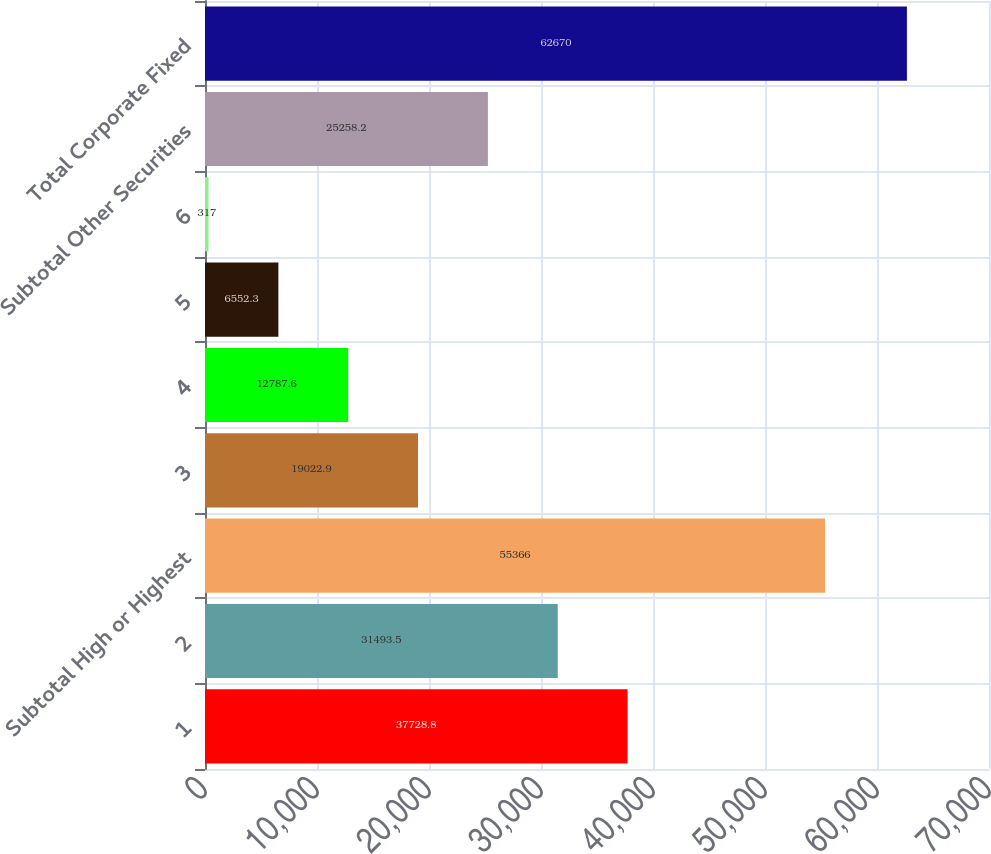<chart> <loc_0><loc_0><loc_500><loc_500><bar_chart><fcel>1<fcel>2<fcel>Subtotal High or Highest<fcel>3<fcel>4<fcel>5<fcel>6<fcel>Subtotal Other Securities<fcel>Total Corporate Fixed<nl><fcel>37728.8<fcel>31493.5<fcel>55366<fcel>19022.9<fcel>12787.6<fcel>6552.3<fcel>317<fcel>25258.2<fcel>62670<nl></chart> 